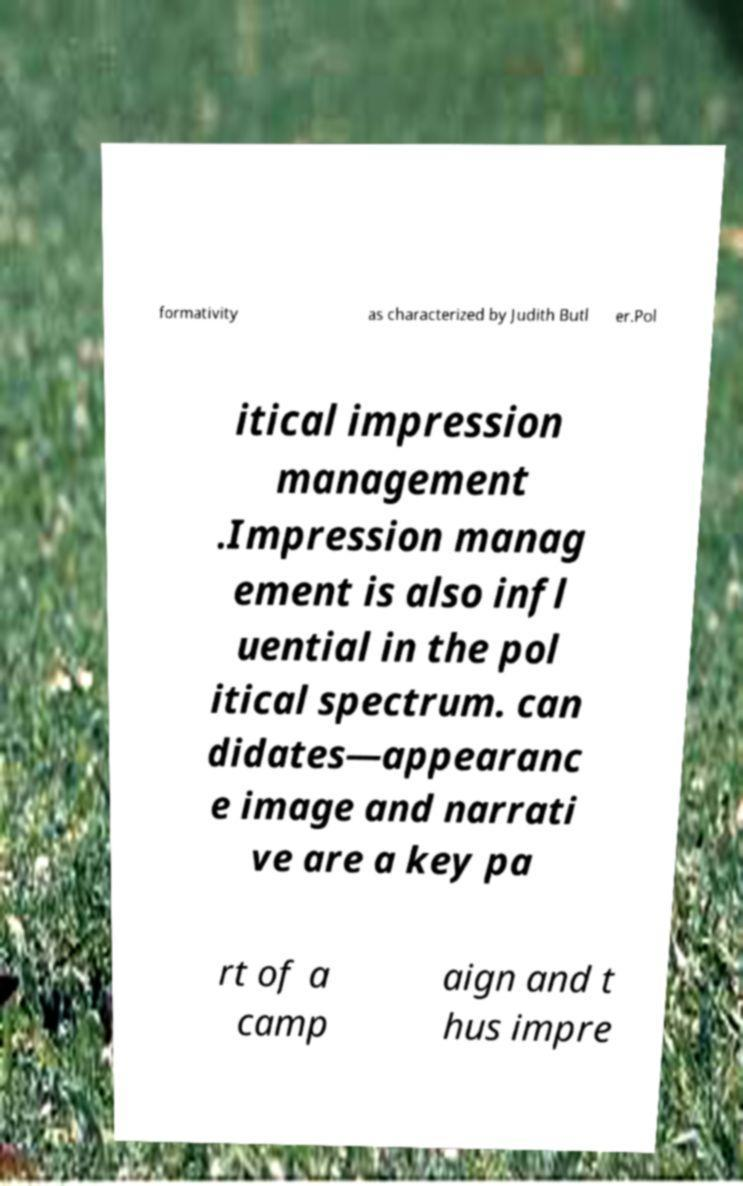Could you extract and type out the text from this image? formativity as characterized by Judith Butl er.Pol itical impression management .Impression manag ement is also infl uential in the pol itical spectrum. can didates—appearanc e image and narrati ve are a key pa rt of a camp aign and t hus impre 